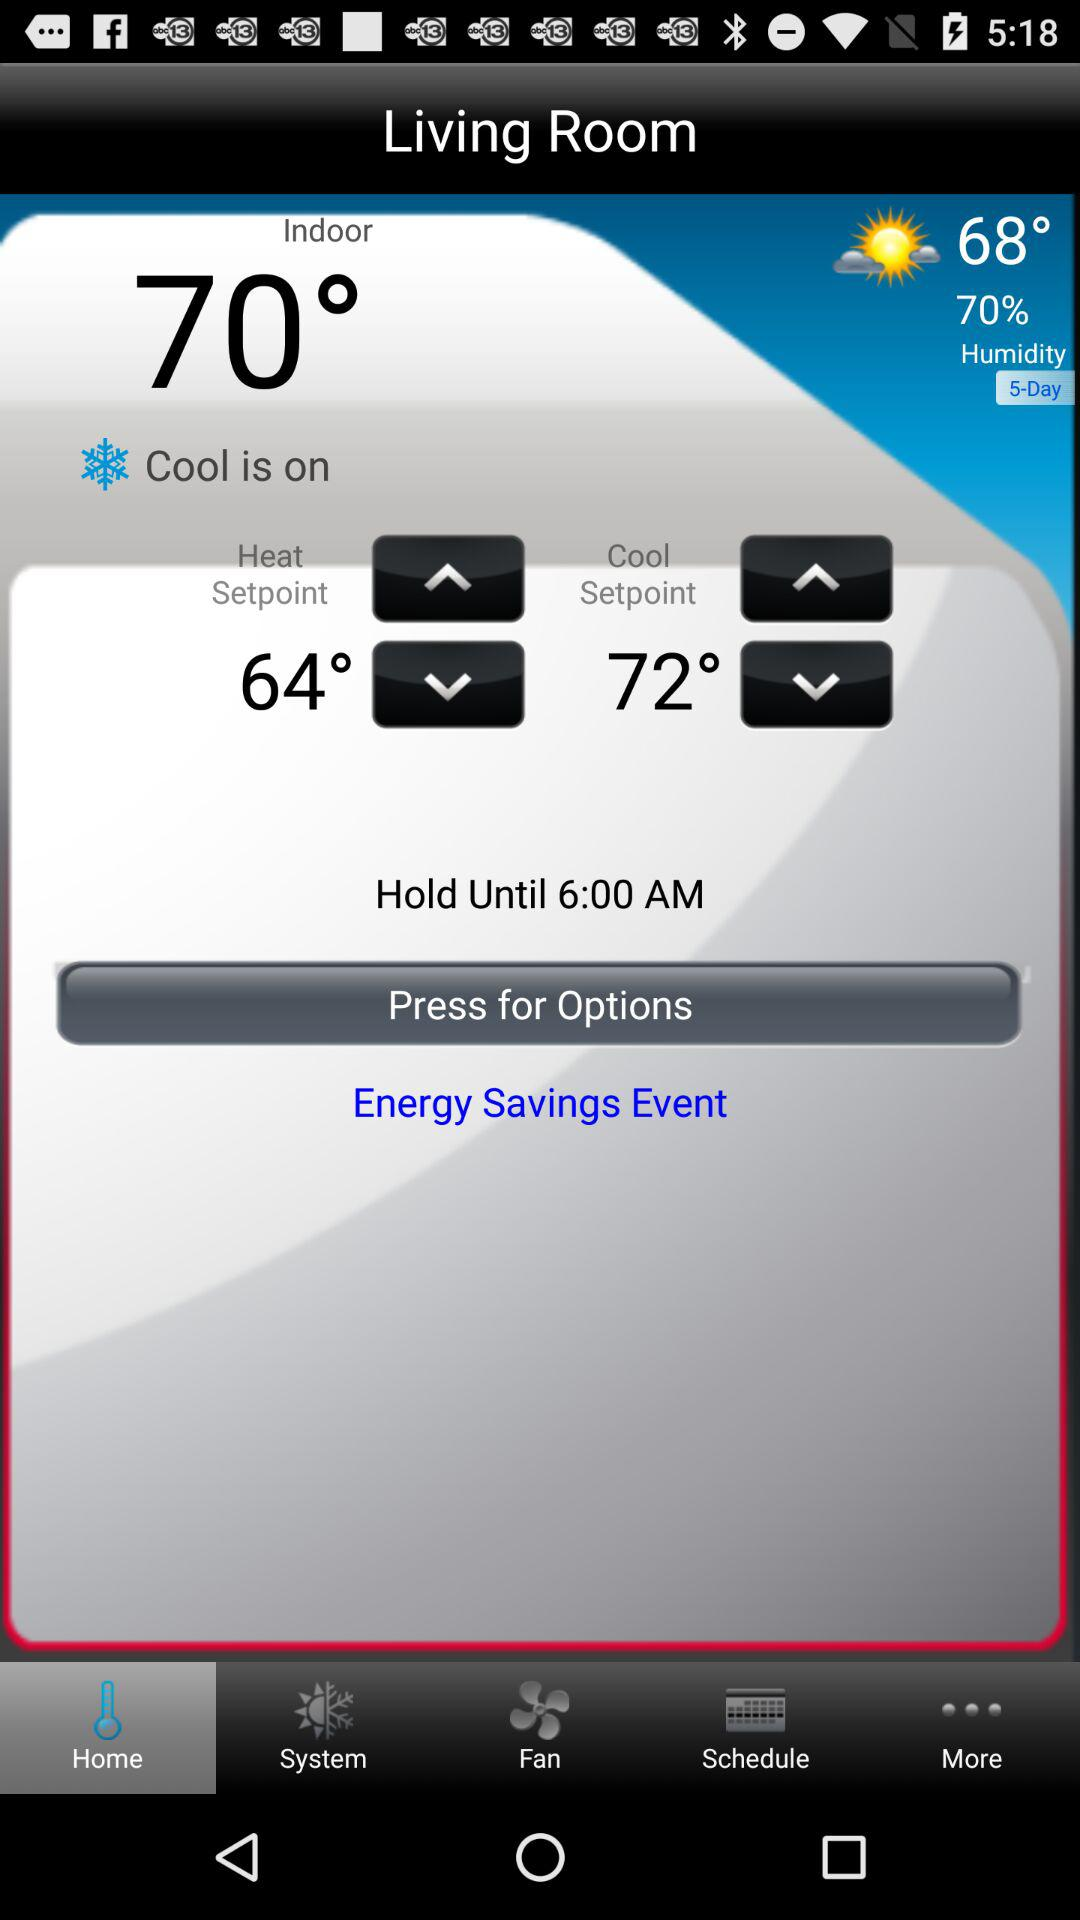What is the indoor climate? The indoor climate is 70°. 